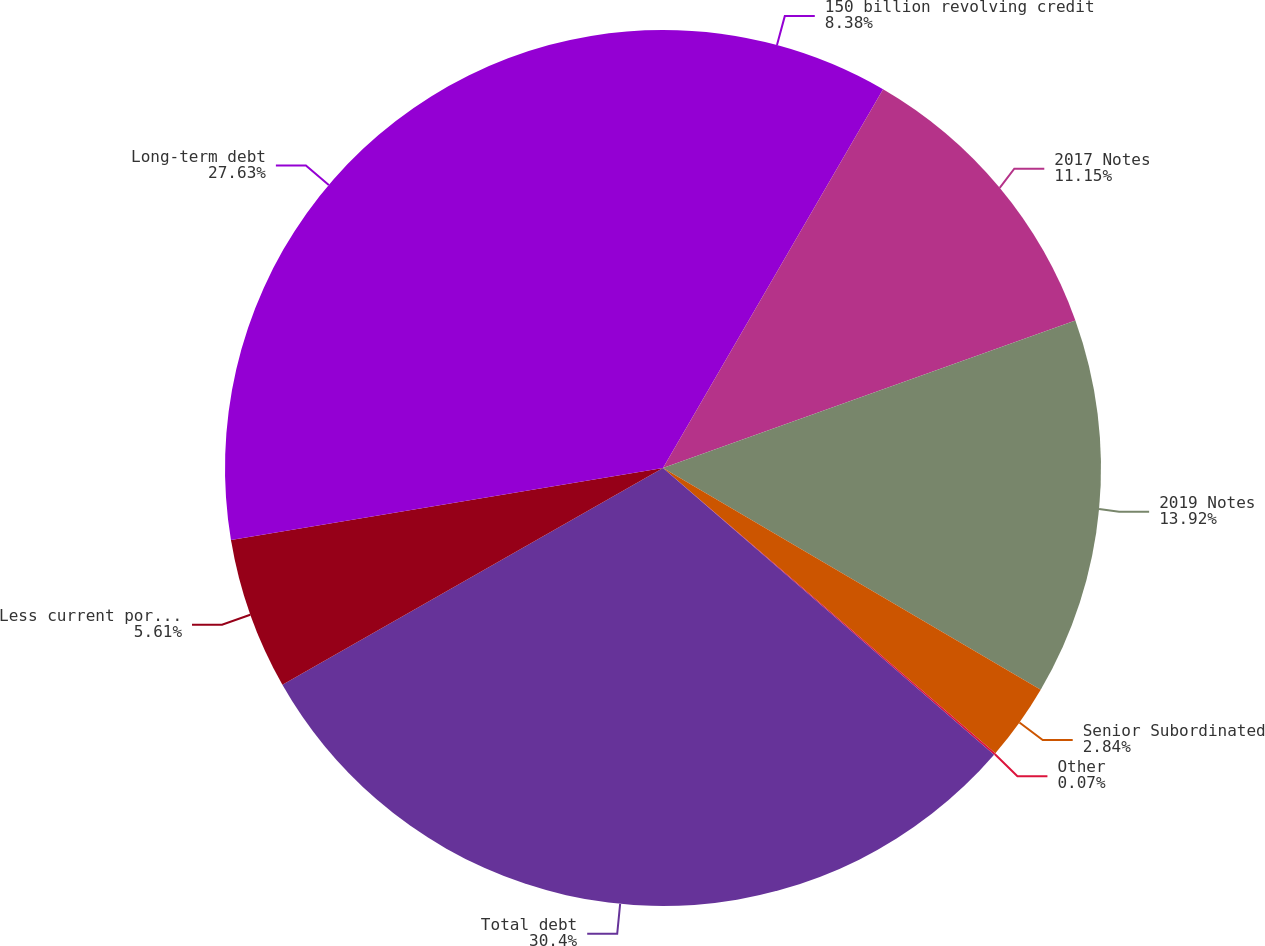Convert chart to OTSL. <chart><loc_0><loc_0><loc_500><loc_500><pie_chart><fcel>150 billion revolving credit<fcel>2017 Notes<fcel>2019 Notes<fcel>Senior Subordinated<fcel>Other<fcel>Total debt<fcel>Less current portion<fcel>Long-term debt<nl><fcel>8.38%<fcel>11.15%<fcel>13.92%<fcel>2.84%<fcel>0.07%<fcel>30.4%<fcel>5.61%<fcel>27.63%<nl></chart> 